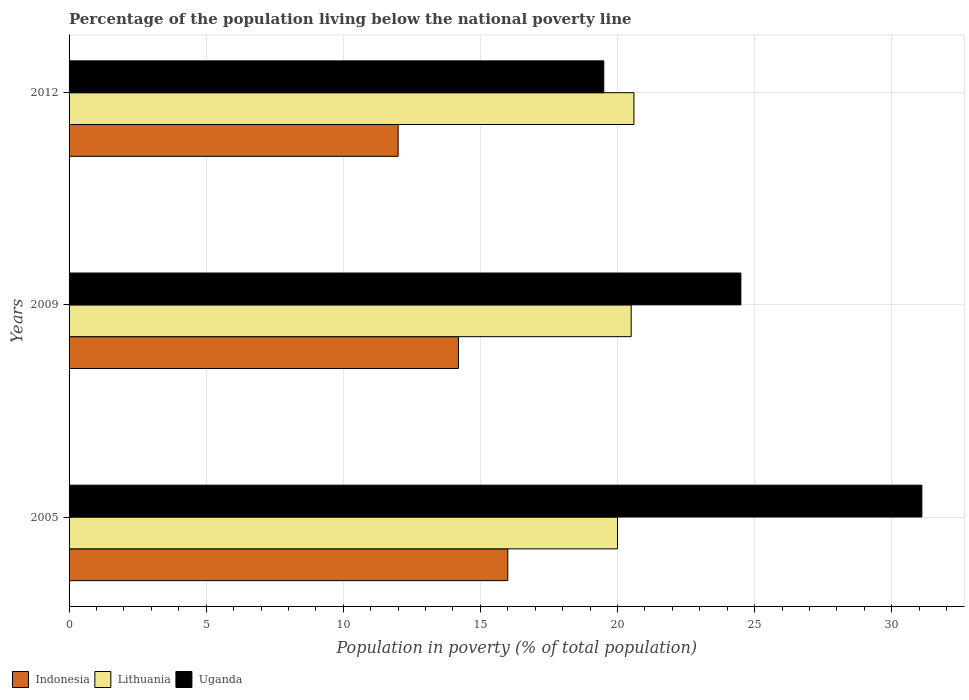Are the number of bars per tick equal to the number of legend labels?
Offer a terse response. Yes. Are the number of bars on each tick of the Y-axis equal?
Your answer should be compact. Yes. Across all years, what is the minimum percentage of the population living below the national poverty line in Indonesia?
Offer a terse response. 12. In which year was the percentage of the population living below the national poverty line in Indonesia maximum?
Offer a terse response. 2005. What is the total percentage of the population living below the national poverty line in Indonesia in the graph?
Make the answer very short. 42.2. What is the difference between the percentage of the population living below the national poverty line in Uganda in 2005 and that in 2009?
Your response must be concise. 6.6. What is the average percentage of the population living below the national poverty line in Lithuania per year?
Provide a short and direct response. 20.37. In the year 2005, what is the difference between the percentage of the population living below the national poverty line in Indonesia and percentage of the population living below the national poverty line in Lithuania?
Your response must be concise. -4. What is the ratio of the percentage of the population living below the national poverty line in Indonesia in 2005 to that in 2009?
Provide a short and direct response. 1.13. Is the difference between the percentage of the population living below the national poverty line in Indonesia in 2009 and 2012 greater than the difference between the percentage of the population living below the national poverty line in Lithuania in 2009 and 2012?
Give a very brief answer. Yes. What is the difference between the highest and the second highest percentage of the population living below the national poverty line in Indonesia?
Keep it short and to the point. 1.8. What is the difference between the highest and the lowest percentage of the population living below the national poverty line in Lithuania?
Your answer should be very brief. 0.6. In how many years, is the percentage of the population living below the national poverty line in Uganda greater than the average percentage of the population living below the national poverty line in Uganda taken over all years?
Keep it short and to the point. 1. Is the sum of the percentage of the population living below the national poverty line in Lithuania in 2005 and 2009 greater than the maximum percentage of the population living below the national poverty line in Uganda across all years?
Offer a very short reply. Yes. What does the 3rd bar from the top in 2009 represents?
Ensure brevity in your answer.  Indonesia. What does the 2nd bar from the bottom in 2009 represents?
Make the answer very short. Lithuania. Is it the case that in every year, the sum of the percentage of the population living below the national poverty line in Uganda and percentage of the population living below the national poverty line in Lithuania is greater than the percentage of the population living below the national poverty line in Indonesia?
Offer a terse response. Yes. How many years are there in the graph?
Keep it short and to the point. 3. What is the difference between two consecutive major ticks on the X-axis?
Your answer should be very brief. 5. Are the values on the major ticks of X-axis written in scientific E-notation?
Offer a terse response. No. Where does the legend appear in the graph?
Your answer should be very brief. Bottom left. How are the legend labels stacked?
Your answer should be very brief. Horizontal. What is the title of the graph?
Offer a terse response. Percentage of the population living below the national poverty line. Does "Uruguay" appear as one of the legend labels in the graph?
Your answer should be compact. No. What is the label or title of the X-axis?
Your answer should be very brief. Population in poverty (% of total population). What is the Population in poverty (% of total population) in Indonesia in 2005?
Keep it short and to the point. 16. What is the Population in poverty (% of total population) in Uganda in 2005?
Your response must be concise. 31.1. What is the Population in poverty (% of total population) of Indonesia in 2009?
Offer a very short reply. 14.2. What is the Population in poverty (% of total population) of Uganda in 2009?
Your answer should be very brief. 24.5. What is the Population in poverty (% of total population) of Indonesia in 2012?
Your answer should be very brief. 12. What is the Population in poverty (% of total population) in Lithuania in 2012?
Your answer should be very brief. 20.6. What is the Population in poverty (% of total population) in Uganda in 2012?
Offer a very short reply. 19.5. Across all years, what is the maximum Population in poverty (% of total population) in Indonesia?
Your answer should be compact. 16. Across all years, what is the maximum Population in poverty (% of total population) of Lithuania?
Provide a succinct answer. 20.6. Across all years, what is the maximum Population in poverty (% of total population) in Uganda?
Your answer should be compact. 31.1. Across all years, what is the minimum Population in poverty (% of total population) in Indonesia?
Make the answer very short. 12. Across all years, what is the minimum Population in poverty (% of total population) in Uganda?
Your response must be concise. 19.5. What is the total Population in poverty (% of total population) of Indonesia in the graph?
Offer a very short reply. 42.2. What is the total Population in poverty (% of total population) of Lithuania in the graph?
Make the answer very short. 61.1. What is the total Population in poverty (% of total population) of Uganda in the graph?
Provide a succinct answer. 75.1. What is the difference between the Population in poverty (% of total population) in Indonesia in 2005 and that in 2009?
Ensure brevity in your answer.  1.8. What is the difference between the Population in poverty (% of total population) in Lithuania in 2005 and that in 2012?
Your answer should be very brief. -0.6. What is the difference between the Population in poverty (% of total population) in Uganda in 2005 and that in 2012?
Your answer should be very brief. 11.6. What is the difference between the Population in poverty (% of total population) of Lithuania in 2009 and that in 2012?
Your response must be concise. -0.1. What is the difference between the Population in poverty (% of total population) of Indonesia in 2005 and the Population in poverty (% of total population) of Uganda in 2009?
Ensure brevity in your answer.  -8.5. What is the difference between the Population in poverty (% of total population) of Indonesia in 2005 and the Population in poverty (% of total population) of Lithuania in 2012?
Provide a succinct answer. -4.6. What is the difference between the Population in poverty (% of total population) in Indonesia in 2005 and the Population in poverty (% of total population) in Uganda in 2012?
Offer a terse response. -3.5. What is the difference between the Population in poverty (% of total population) in Lithuania in 2005 and the Population in poverty (% of total population) in Uganda in 2012?
Give a very brief answer. 0.5. What is the difference between the Population in poverty (% of total population) of Indonesia in 2009 and the Population in poverty (% of total population) of Uganda in 2012?
Make the answer very short. -5.3. What is the average Population in poverty (% of total population) in Indonesia per year?
Provide a succinct answer. 14.07. What is the average Population in poverty (% of total population) of Lithuania per year?
Provide a succinct answer. 20.37. What is the average Population in poverty (% of total population) of Uganda per year?
Offer a terse response. 25.03. In the year 2005, what is the difference between the Population in poverty (% of total population) of Indonesia and Population in poverty (% of total population) of Lithuania?
Provide a short and direct response. -4. In the year 2005, what is the difference between the Population in poverty (% of total population) of Indonesia and Population in poverty (% of total population) of Uganda?
Give a very brief answer. -15.1. In the year 2005, what is the difference between the Population in poverty (% of total population) of Lithuania and Population in poverty (% of total population) of Uganda?
Your answer should be compact. -11.1. In the year 2009, what is the difference between the Population in poverty (% of total population) of Indonesia and Population in poverty (% of total population) of Lithuania?
Your answer should be very brief. -6.3. In the year 2012, what is the difference between the Population in poverty (% of total population) in Indonesia and Population in poverty (% of total population) in Lithuania?
Provide a succinct answer. -8.6. In the year 2012, what is the difference between the Population in poverty (% of total population) in Indonesia and Population in poverty (% of total population) in Uganda?
Offer a very short reply. -7.5. In the year 2012, what is the difference between the Population in poverty (% of total population) in Lithuania and Population in poverty (% of total population) in Uganda?
Offer a very short reply. 1.1. What is the ratio of the Population in poverty (% of total population) in Indonesia in 2005 to that in 2009?
Make the answer very short. 1.13. What is the ratio of the Population in poverty (% of total population) in Lithuania in 2005 to that in 2009?
Your answer should be compact. 0.98. What is the ratio of the Population in poverty (% of total population) in Uganda in 2005 to that in 2009?
Provide a short and direct response. 1.27. What is the ratio of the Population in poverty (% of total population) in Lithuania in 2005 to that in 2012?
Ensure brevity in your answer.  0.97. What is the ratio of the Population in poverty (% of total population) of Uganda in 2005 to that in 2012?
Provide a succinct answer. 1.59. What is the ratio of the Population in poverty (% of total population) in Indonesia in 2009 to that in 2012?
Ensure brevity in your answer.  1.18. What is the ratio of the Population in poverty (% of total population) of Uganda in 2009 to that in 2012?
Keep it short and to the point. 1.26. What is the difference between the highest and the second highest Population in poverty (% of total population) in Lithuania?
Your answer should be very brief. 0.1. 